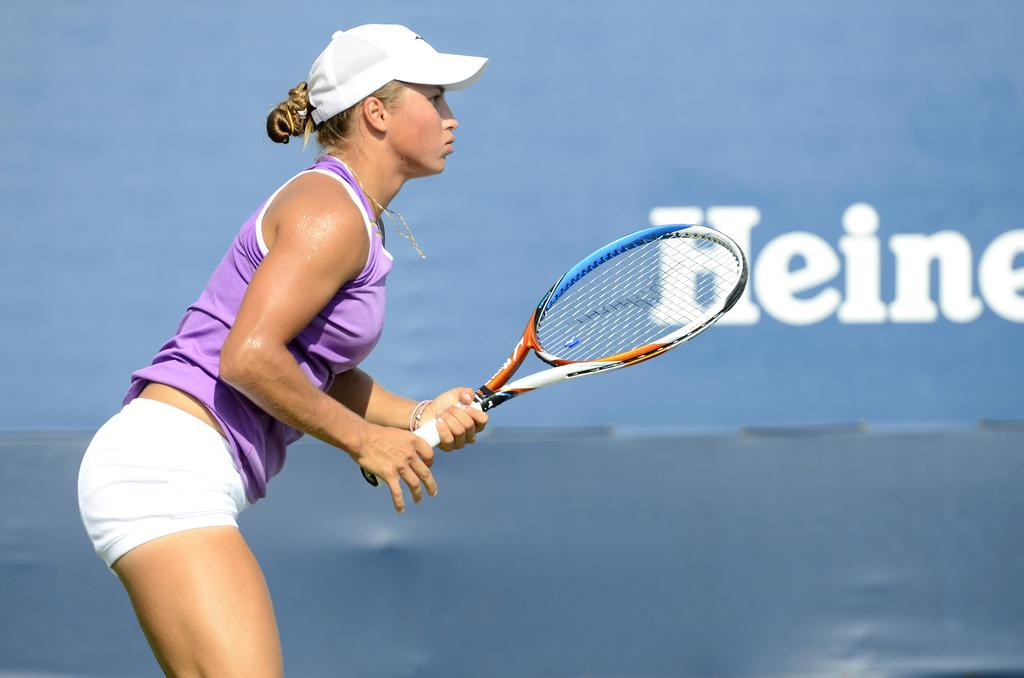What can be seen in the background of the image? There is a hoarding in the background of the image. What is the woman in the image doing? The woman is standing and holding a tennis racket. What is the woman wearing on her head? The woman is wearing a white cap. What type of trouble is the woman causing with the wax in the image? There is no wax present in the image, and therefore no trouble can be caused by it. 